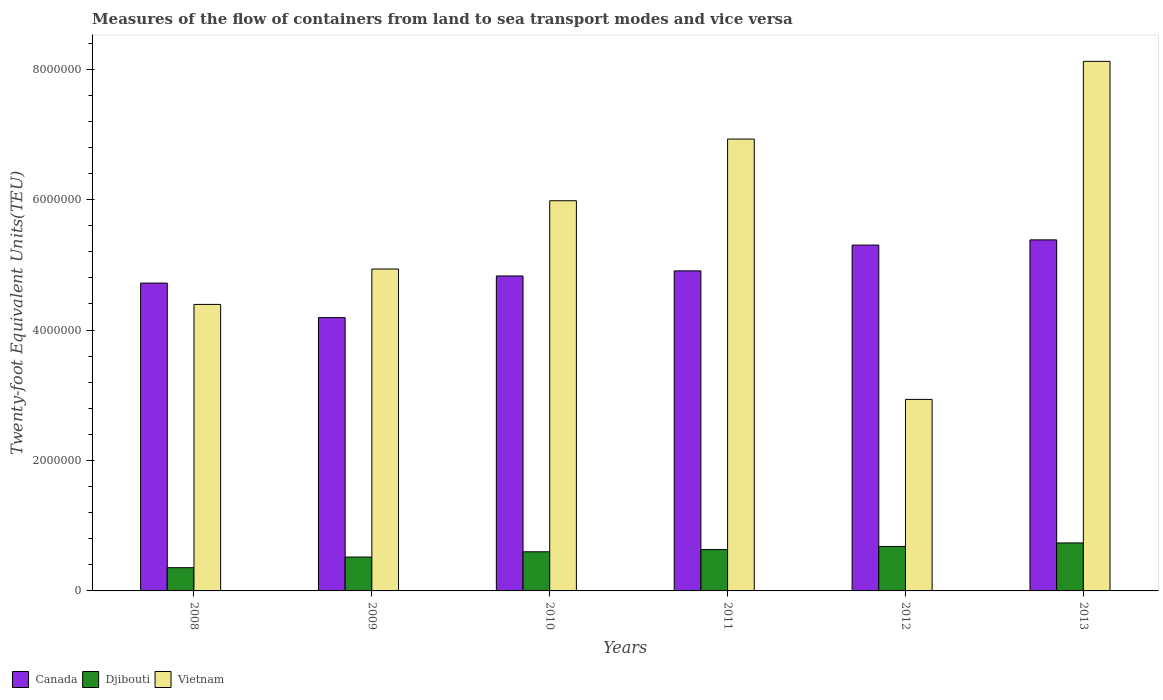How many different coloured bars are there?
Make the answer very short. 3. Are the number of bars per tick equal to the number of legend labels?
Provide a short and direct response. Yes. How many bars are there on the 1st tick from the left?
Ensure brevity in your answer.  3. What is the label of the 4th group of bars from the left?
Your answer should be compact. 2011. What is the container port traffic in Vietnam in 2008?
Ensure brevity in your answer.  4.39e+06. Across all years, what is the maximum container port traffic in Canada?
Your answer should be very brief. 5.38e+06. Across all years, what is the minimum container port traffic in Vietnam?
Your answer should be compact. 2.94e+06. What is the total container port traffic in Djibouti in the graph?
Give a very brief answer. 3.53e+06. What is the difference between the container port traffic in Canada in 2012 and that in 2013?
Make the answer very short. -7.98e+04. What is the difference between the container port traffic in Canada in 2009 and the container port traffic in Djibouti in 2012?
Make the answer very short. 3.51e+06. What is the average container port traffic in Djibouti per year?
Give a very brief answer. 5.88e+05. In the year 2008, what is the difference between the container port traffic in Djibouti and container port traffic in Vietnam?
Your answer should be very brief. -4.04e+06. What is the ratio of the container port traffic in Canada in 2009 to that in 2012?
Keep it short and to the point. 0.79. Is the difference between the container port traffic in Djibouti in 2009 and 2013 greater than the difference between the container port traffic in Vietnam in 2009 and 2013?
Your answer should be compact. Yes. What is the difference between the highest and the second highest container port traffic in Vietnam?
Make the answer very short. 1.19e+06. What is the difference between the highest and the lowest container port traffic in Vietnam?
Ensure brevity in your answer.  5.18e+06. In how many years, is the container port traffic in Canada greater than the average container port traffic in Canada taken over all years?
Your answer should be very brief. 3. What does the 2nd bar from the left in 2011 represents?
Keep it short and to the point. Djibouti. What does the 3rd bar from the right in 2012 represents?
Give a very brief answer. Canada. How many bars are there?
Keep it short and to the point. 18. What is the difference between two consecutive major ticks on the Y-axis?
Offer a terse response. 2.00e+06. Are the values on the major ticks of Y-axis written in scientific E-notation?
Keep it short and to the point. No. Does the graph contain any zero values?
Your response must be concise. No. Does the graph contain grids?
Make the answer very short. No. What is the title of the graph?
Offer a terse response. Measures of the flow of containers from land to sea transport modes and vice versa. What is the label or title of the Y-axis?
Ensure brevity in your answer.  Twenty-foot Equivalent Units(TEU). What is the Twenty-foot Equivalent Units(TEU) of Canada in 2008?
Provide a short and direct response. 4.72e+06. What is the Twenty-foot Equivalent Units(TEU) in Djibouti in 2008?
Your answer should be very brief. 3.56e+05. What is the Twenty-foot Equivalent Units(TEU) of Vietnam in 2008?
Your answer should be very brief. 4.39e+06. What is the Twenty-foot Equivalent Units(TEU) in Canada in 2009?
Provide a succinct answer. 4.19e+06. What is the Twenty-foot Equivalent Units(TEU) in Djibouti in 2009?
Provide a succinct answer. 5.20e+05. What is the Twenty-foot Equivalent Units(TEU) of Vietnam in 2009?
Your answer should be very brief. 4.94e+06. What is the Twenty-foot Equivalent Units(TEU) in Canada in 2010?
Ensure brevity in your answer.  4.83e+06. What is the Twenty-foot Equivalent Units(TEU) of Vietnam in 2010?
Offer a terse response. 5.98e+06. What is the Twenty-foot Equivalent Units(TEU) in Canada in 2011?
Your answer should be compact. 4.91e+06. What is the Twenty-foot Equivalent Units(TEU) in Djibouti in 2011?
Your response must be concise. 6.34e+05. What is the Twenty-foot Equivalent Units(TEU) in Vietnam in 2011?
Offer a terse response. 6.93e+06. What is the Twenty-foot Equivalent Units(TEU) of Canada in 2012?
Provide a succinct answer. 5.30e+06. What is the Twenty-foot Equivalent Units(TEU) of Djibouti in 2012?
Provide a succinct answer. 6.82e+05. What is the Twenty-foot Equivalent Units(TEU) of Vietnam in 2012?
Your answer should be compact. 2.94e+06. What is the Twenty-foot Equivalent Units(TEU) in Canada in 2013?
Keep it short and to the point. 5.38e+06. What is the Twenty-foot Equivalent Units(TEU) of Djibouti in 2013?
Give a very brief answer. 7.36e+05. What is the Twenty-foot Equivalent Units(TEU) in Vietnam in 2013?
Ensure brevity in your answer.  8.12e+06. Across all years, what is the maximum Twenty-foot Equivalent Units(TEU) of Canada?
Provide a succinct answer. 5.38e+06. Across all years, what is the maximum Twenty-foot Equivalent Units(TEU) in Djibouti?
Provide a succinct answer. 7.36e+05. Across all years, what is the maximum Twenty-foot Equivalent Units(TEU) of Vietnam?
Offer a very short reply. 8.12e+06. Across all years, what is the minimum Twenty-foot Equivalent Units(TEU) in Canada?
Your answer should be compact. 4.19e+06. Across all years, what is the minimum Twenty-foot Equivalent Units(TEU) of Djibouti?
Provide a succinct answer. 3.56e+05. Across all years, what is the minimum Twenty-foot Equivalent Units(TEU) in Vietnam?
Keep it short and to the point. 2.94e+06. What is the total Twenty-foot Equivalent Units(TEU) of Canada in the graph?
Your response must be concise. 2.93e+07. What is the total Twenty-foot Equivalent Units(TEU) in Djibouti in the graph?
Your answer should be compact. 3.53e+06. What is the total Twenty-foot Equivalent Units(TEU) of Vietnam in the graph?
Give a very brief answer. 3.33e+07. What is the difference between the Twenty-foot Equivalent Units(TEU) of Canada in 2008 and that in 2009?
Ensure brevity in your answer.  5.29e+05. What is the difference between the Twenty-foot Equivalent Units(TEU) in Djibouti in 2008 and that in 2009?
Ensure brevity in your answer.  -1.63e+05. What is the difference between the Twenty-foot Equivalent Units(TEU) in Vietnam in 2008 and that in 2009?
Provide a short and direct response. -5.43e+05. What is the difference between the Twenty-foot Equivalent Units(TEU) in Canada in 2008 and that in 2010?
Make the answer very short. -1.09e+05. What is the difference between the Twenty-foot Equivalent Units(TEU) of Djibouti in 2008 and that in 2010?
Your response must be concise. -2.44e+05. What is the difference between the Twenty-foot Equivalent Units(TEU) in Vietnam in 2008 and that in 2010?
Make the answer very short. -1.59e+06. What is the difference between the Twenty-foot Equivalent Units(TEU) in Canada in 2008 and that in 2011?
Your answer should be very brief. -1.87e+05. What is the difference between the Twenty-foot Equivalent Units(TEU) of Djibouti in 2008 and that in 2011?
Ensure brevity in your answer.  -2.78e+05. What is the difference between the Twenty-foot Equivalent Units(TEU) in Vietnam in 2008 and that in 2011?
Your answer should be compact. -2.54e+06. What is the difference between the Twenty-foot Equivalent Units(TEU) of Canada in 2008 and that in 2012?
Provide a short and direct response. -5.83e+05. What is the difference between the Twenty-foot Equivalent Units(TEU) of Djibouti in 2008 and that in 2012?
Make the answer very short. -3.25e+05. What is the difference between the Twenty-foot Equivalent Units(TEU) in Vietnam in 2008 and that in 2012?
Provide a succinct answer. 1.46e+06. What is the difference between the Twenty-foot Equivalent Units(TEU) of Canada in 2008 and that in 2013?
Keep it short and to the point. -6.63e+05. What is the difference between the Twenty-foot Equivalent Units(TEU) of Djibouti in 2008 and that in 2013?
Ensure brevity in your answer.  -3.79e+05. What is the difference between the Twenty-foot Equivalent Units(TEU) of Vietnam in 2008 and that in 2013?
Ensure brevity in your answer.  -3.73e+06. What is the difference between the Twenty-foot Equivalent Units(TEU) of Canada in 2009 and that in 2010?
Offer a very short reply. -6.38e+05. What is the difference between the Twenty-foot Equivalent Units(TEU) in Djibouti in 2009 and that in 2010?
Give a very brief answer. -8.05e+04. What is the difference between the Twenty-foot Equivalent Units(TEU) in Vietnam in 2009 and that in 2010?
Offer a terse response. -1.05e+06. What is the difference between the Twenty-foot Equivalent Units(TEU) of Canada in 2009 and that in 2011?
Your response must be concise. -7.17e+05. What is the difference between the Twenty-foot Equivalent Units(TEU) in Djibouti in 2009 and that in 2011?
Provide a short and direct response. -1.15e+05. What is the difference between the Twenty-foot Equivalent Units(TEU) in Vietnam in 2009 and that in 2011?
Make the answer very short. -1.99e+06. What is the difference between the Twenty-foot Equivalent Units(TEU) of Canada in 2009 and that in 2012?
Provide a short and direct response. -1.11e+06. What is the difference between the Twenty-foot Equivalent Units(TEU) in Djibouti in 2009 and that in 2012?
Provide a short and direct response. -1.62e+05. What is the difference between the Twenty-foot Equivalent Units(TEU) of Vietnam in 2009 and that in 2012?
Provide a succinct answer. 2.00e+06. What is the difference between the Twenty-foot Equivalent Units(TEU) in Canada in 2009 and that in 2013?
Ensure brevity in your answer.  -1.19e+06. What is the difference between the Twenty-foot Equivalent Units(TEU) in Djibouti in 2009 and that in 2013?
Give a very brief answer. -2.16e+05. What is the difference between the Twenty-foot Equivalent Units(TEU) in Vietnam in 2009 and that in 2013?
Offer a terse response. -3.18e+06. What is the difference between the Twenty-foot Equivalent Units(TEU) of Canada in 2010 and that in 2011?
Your response must be concise. -7.83e+04. What is the difference between the Twenty-foot Equivalent Units(TEU) in Djibouti in 2010 and that in 2011?
Your answer should be very brief. -3.42e+04. What is the difference between the Twenty-foot Equivalent Units(TEU) in Vietnam in 2010 and that in 2011?
Your response must be concise. -9.46e+05. What is the difference between the Twenty-foot Equivalent Units(TEU) in Canada in 2010 and that in 2012?
Provide a succinct answer. -4.74e+05. What is the difference between the Twenty-foot Equivalent Units(TEU) in Djibouti in 2010 and that in 2012?
Give a very brief answer. -8.18e+04. What is the difference between the Twenty-foot Equivalent Units(TEU) of Vietnam in 2010 and that in 2012?
Your answer should be very brief. 3.05e+06. What is the difference between the Twenty-foot Equivalent Units(TEU) of Canada in 2010 and that in 2013?
Keep it short and to the point. -5.54e+05. What is the difference between the Twenty-foot Equivalent Units(TEU) in Djibouti in 2010 and that in 2013?
Keep it short and to the point. -1.36e+05. What is the difference between the Twenty-foot Equivalent Units(TEU) of Vietnam in 2010 and that in 2013?
Offer a very short reply. -2.14e+06. What is the difference between the Twenty-foot Equivalent Units(TEU) in Canada in 2011 and that in 2012?
Your answer should be very brief. -3.96e+05. What is the difference between the Twenty-foot Equivalent Units(TEU) of Djibouti in 2011 and that in 2012?
Make the answer very short. -4.76e+04. What is the difference between the Twenty-foot Equivalent Units(TEU) in Vietnam in 2011 and that in 2012?
Give a very brief answer. 3.99e+06. What is the difference between the Twenty-foot Equivalent Units(TEU) of Canada in 2011 and that in 2013?
Your answer should be compact. -4.75e+05. What is the difference between the Twenty-foot Equivalent Units(TEU) of Djibouti in 2011 and that in 2013?
Give a very brief answer. -1.01e+05. What is the difference between the Twenty-foot Equivalent Units(TEU) of Vietnam in 2011 and that in 2013?
Keep it short and to the point. -1.19e+06. What is the difference between the Twenty-foot Equivalent Units(TEU) in Canada in 2012 and that in 2013?
Your answer should be compact. -7.98e+04. What is the difference between the Twenty-foot Equivalent Units(TEU) in Djibouti in 2012 and that in 2013?
Your answer should be compact. -5.39e+04. What is the difference between the Twenty-foot Equivalent Units(TEU) of Vietnam in 2012 and that in 2013?
Ensure brevity in your answer.  -5.18e+06. What is the difference between the Twenty-foot Equivalent Units(TEU) in Canada in 2008 and the Twenty-foot Equivalent Units(TEU) in Djibouti in 2009?
Your response must be concise. 4.20e+06. What is the difference between the Twenty-foot Equivalent Units(TEU) in Canada in 2008 and the Twenty-foot Equivalent Units(TEU) in Vietnam in 2009?
Make the answer very short. -2.16e+05. What is the difference between the Twenty-foot Equivalent Units(TEU) in Djibouti in 2008 and the Twenty-foot Equivalent Units(TEU) in Vietnam in 2009?
Offer a terse response. -4.58e+06. What is the difference between the Twenty-foot Equivalent Units(TEU) of Canada in 2008 and the Twenty-foot Equivalent Units(TEU) of Djibouti in 2010?
Give a very brief answer. 4.12e+06. What is the difference between the Twenty-foot Equivalent Units(TEU) of Canada in 2008 and the Twenty-foot Equivalent Units(TEU) of Vietnam in 2010?
Ensure brevity in your answer.  -1.26e+06. What is the difference between the Twenty-foot Equivalent Units(TEU) of Djibouti in 2008 and the Twenty-foot Equivalent Units(TEU) of Vietnam in 2010?
Offer a very short reply. -5.63e+06. What is the difference between the Twenty-foot Equivalent Units(TEU) in Canada in 2008 and the Twenty-foot Equivalent Units(TEU) in Djibouti in 2011?
Keep it short and to the point. 4.09e+06. What is the difference between the Twenty-foot Equivalent Units(TEU) of Canada in 2008 and the Twenty-foot Equivalent Units(TEU) of Vietnam in 2011?
Offer a very short reply. -2.21e+06. What is the difference between the Twenty-foot Equivalent Units(TEU) of Djibouti in 2008 and the Twenty-foot Equivalent Units(TEU) of Vietnam in 2011?
Make the answer very short. -6.57e+06. What is the difference between the Twenty-foot Equivalent Units(TEU) in Canada in 2008 and the Twenty-foot Equivalent Units(TEU) in Djibouti in 2012?
Your answer should be very brief. 4.04e+06. What is the difference between the Twenty-foot Equivalent Units(TEU) in Canada in 2008 and the Twenty-foot Equivalent Units(TEU) in Vietnam in 2012?
Your answer should be compact. 1.78e+06. What is the difference between the Twenty-foot Equivalent Units(TEU) in Djibouti in 2008 and the Twenty-foot Equivalent Units(TEU) in Vietnam in 2012?
Ensure brevity in your answer.  -2.58e+06. What is the difference between the Twenty-foot Equivalent Units(TEU) in Canada in 2008 and the Twenty-foot Equivalent Units(TEU) in Djibouti in 2013?
Your answer should be very brief. 3.99e+06. What is the difference between the Twenty-foot Equivalent Units(TEU) in Canada in 2008 and the Twenty-foot Equivalent Units(TEU) in Vietnam in 2013?
Ensure brevity in your answer.  -3.40e+06. What is the difference between the Twenty-foot Equivalent Units(TEU) of Djibouti in 2008 and the Twenty-foot Equivalent Units(TEU) of Vietnam in 2013?
Give a very brief answer. -7.76e+06. What is the difference between the Twenty-foot Equivalent Units(TEU) of Canada in 2009 and the Twenty-foot Equivalent Units(TEU) of Djibouti in 2010?
Your answer should be very brief. 3.59e+06. What is the difference between the Twenty-foot Equivalent Units(TEU) in Canada in 2009 and the Twenty-foot Equivalent Units(TEU) in Vietnam in 2010?
Provide a short and direct response. -1.79e+06. What is the difference between the Twenty-foot Equivalent Units(TEU) in Djibouti in 2009 and the Twenty-foot Equivalent Units(TEU) in Vietnam in 2010?
Offer a terse response. -5.46e+06. What is the difference between the Twenty-foot Equivalent Units(TEU) of Canada in 2009 and the Twenty-foot Equivalent Units(TEU) of Djibouti in 2011?
Your answer should be compact. 3.56e+06. What is the difference between the Twenty-foot Equivalent Units(TEU) in Canada in 2009 and the Twenty-foot Equivalent Units(TEU) in Vietnam in 2011?
Provide a short and direct response. -2.74e+06. What is the difference between the Twenty-foot Equivalent Units(TEU) in Djibouti in 2009 and the Twenty-foot Equivalent Units(TEU) in Vietnam in 2011?
Offer a very short reply. -6.41e+06. What is the difference between the Twenty-foot Equivalent Units(TEU) in Canada in 2009 and the Twenty-foot Equivalent Units(TEU) in Djibouti in 2012?
Offer a terse response. 3.51e+06. What is the difference between the Twenty-foot Equivalent Units(TEU) of Canada in 2009 and the Twenty-foot Equivalent Units(TEU) of Vietnam in 2012?
Provide a short and direct response. 1.25e+06. What is the difference between the Twenty-foot Equivalent Units(TEU) of Djibouti in 2009 and the Twenty-foot Equivalent Units(TEU) of Vietnam in 2012?
Keep it short and to the point. -2.42e+06. What is the difference between the Twenty-foot Equivalent Units(TEU) of Canada in 2009 and the Twenty-foot Equivalent Units(TEU) of Djibouti in 2013?
Your answer should be very brief. 3.46e+06. What is the difference between the Twenty-foot Equivalent Units(TEU) of Canada in 2009 and the Twenty-foot Equivalent Units(TEU) of Vietnam in 2013?
Make the answer very short. -3.93e+06. What is the difference between the Twenty-foot Equivalent Units(TEU) of Djibouti in 2009 and the Twenty-foot Equivalent Units(TEU) of Vietnam in 2013?
Provide a succinct answer. -7.60e+06. What is the difference between the Twenty-foot Equivalent Units(TEU) in Canada in 2010 and the Twenty-foot Equivalent Units(TEU) in Djibouti in 2011?
Offer a very short reply. 4.20e+06. What is the difference between the Twenty-foot Equivalent Units(TEU) in Canada in 2010 and the Twenty-foot Equivalent Units(TEU) in Vietnam in 2011?
Provide a short and direct response. -2.10e+06. What is the difference between the Twenty-foot Equivalent Units(TEU) of Djibouti in 2010 and the Twenty-foot Equivalent Units(TEU) of Vietnam in 2011?
Offer a very short reply. -6.33e+06. What is the difference between the Twenty-foot Equivalent Units(TEU) of Canada in 2010 and the Twenty-foot Equivalent Units(TEU) of Djibouti in 2012?
Make the answer very short. 4.15e+06. What is the difference between the Twenty-foot Equivalent Units(TEU) in Canada in 2010 and the Twenty-foot Equivalent Units(TEU) in Vietnam in 2012?
Your response must be concise. 1.89e+06. What is the difference between the Twenty-foot Equivalent Units(TEU) in Djibouti in 2010 and the Twenty-foot Equivalent Units(TEU) in Vietnam in 2012?
Give a very brief answer. -2.34e+06. What is the difference between the Twenty-foot Equivalent Units(TEU) in Canada in 2010 and the Twenty-foot Equivalent Units(TEU) in Djibouti in 2013?
Provide a succinct answer. 4.09e+06. What is the difference between the Twenty-foot Equivalent Units(TEU) in Canada in 2010 and the Twenty-foot Equivalent Units(TEU) in Vietnam in 2013?
Your answer should be very brief. -3.29e+06. What is the difference between the Twenty-foot Equivalent Units(TEU) of Djibouti in 2010 and the Twenty-foot Equivalent Units(TEU) of Vietnam in 2013?
Your answer should be compact. -7.52e+06. What is the difference between the Twenty-foot Equivalent Units(TEU) of Canada in 2011 and the Twenty-foot Equivalent Units(TEU) of Djibouti in 2012?
Ensure brevity in your answer.  4.23e+06. What is the difference between the Twenty-foot Equivalent Units(TEU) in Canada in 2011 and the Twenty-foot Equivalent Units(TEU) in Vietnam in 2012?
Keep it short and to the point. 1.97e+06. What is the difference between the Twenty-foot Equivalent Units(TEU) of Djibouti in 2011 and the Twenty-foot Equivalent Units(TEU) of Vietnam in 2012?
Give a very brief answer. -2.30e+06. What is the difference between the Twenty-foot Equivalent Units(TEU) in Canada in 2011 and the Twenty-foot Equivalent Units(TEU) in Djibouti in 2013?
Your response must be concise. 4.17e+06. What is the difference between the Twenty-foot Equivalent Units(TEU) of Canada in 2011 and the Twenty-foot Equivalent Units(TEU) of Vietnam in 2013?
Offer a very short reply. -3.21e+06. What is the difference between the Twenty-foot Equivalent Units(TEU) of Djibouti in 2011 and the Twenty-foot Equivalent Units(TEU) of Vietnam in 2013?
Your answer should be very brief. -7.49e+06. What is the difference between the Twenty-foot Equivalent Units(TEU) in Canada in 2012 and the Twenty-foot Equivalent Units(TEU) in Djibouti in 2013?
Ensure brevity in your answer.  4.57e+06. What is the difference between the Twenty-foot Equivalent Units(TEU) of Canada in 2012 and the Twenty-foot Equivalent Units(TEU) of Vietnam in 2013?
Give a very brief answer. -2.82e+06. What is the difference between the Twenty-foot Equivalent Units(TEU) in Djibouti in 2012 and the Twenty-foot Equivalent Units(TEU) in Vietnam in 2013?
Offer a very short reply. -7.44e+06. What is the average Twenty-foot Equivalent Units(TEU) of Canada per year?
Make the answer very short. 4.89e+06. What is the average Twenty-foot Equivalent Units(TEU) of Djibouti per year?
Ensure brevity in your answer.  5.88e+05. What is the average Twenty-foot Equivalent Units(TEU) in Vietnam per year?
Your answer should be very brief. 5.55e+06. In the year 2008, what is the difference between the Twenty-foot Equivalent Units(TEU) in Canada and Twenty-foot Equivalent Units(TEU) in Djibouti?
Offer a terse response. 4.36e+06. In the year 2008, what is the difference between the Twenty-foot Equivalent Units(TEU) of Canada and Twenty-foot Equivalent Units(TEU) of Vietnam?
Give a very brief answer. 3.27e+05. In the year 2008, what is the difference between the Twenty-foot Equivalent Units(TEU) of Djibouti and Twenty-foot Equivalent Units(TEU) of Vietnam?
Offer a terse response. -4.04e+06. In the year 2009, what is the difference between the Twenty-foot Equivalent Units(TEU) of Canada and Twenty-foot Equivalent Units(TEU) of Djibouti?
Offer a terse response. 3.67e+06. In the year 2009, what is the difference between the Twenty-foot Equivalent Units(TEU) in Canada and Twenty-foot Equivalent Units(TEU) in Vietnam?
Your response must be concise. -7.45e+05. In the year 2009, what is the difference between the Twenty-foot Equivalent Units(TEU) in Djibouti and Twenty-foot Equivalent Units(TEU) in Vietnam?
Give a very brief answer. -4.42e+06. In the year 2010, what is the difference between the Twenty-foot Equivalent Units(TEU) of Canada and Twenty-foot Equivalent Units(TEU) of Djibouti?
Ensure brevity in your answer.  4.23e+06. In the year 2010, what is the difference between the Twenty-foot Equivalent Units(TEU) in Canada and Twenty-foot Equivalent Units(TEU) in Vietnam?
Your answer should be very brief. -1.15e+06. In the year 2010, what is the difference between the Twenty-foot Equivalent Units(TEU) of Djibouti and Twenty-foot Equivalent Units(TEU) of Vietnam?
Give a very brief answer. -5.38e+06. In the year 2011, what is the difference between the Twenty-foot Equivalent Units(TEU) of Canada and Twenty-foot Equivalent Units(TEU) of Djibouti?
Provide a succinct answer. 4.27e+06. In the year 2011, what is the difference between the Twenty-foot Equivalent Units(TEU) of Canada and Twenty-foot Equivalent Units(TEU) of Vietnam?
Provide a short and direct response. -2.02e+06. In the year 2011, what is the difference between the Twenty-foot Equivalent Units(TEU) of Djibouti and Twenty-foot Equivalent Units(TEU) of Vietnam?
Your answer should be very brief. -6.30e+06. In the year 2012, what is the difference between the Twenty-foot Equivalent Units(TEU) of Canada and Twenty-foot Equivalent Units(TEU) of Djibouti?
Give a very brief answer. 4.62e+06. In the year 2012, what is the difference between the Twenty-foot Equivalent Units(TEU) in Canada and Twenty-foot Equivalent Units(TEU) in Vietnam?
Provide a succinct answer. 2.37e+06. In the year 2012, what is the difference between the Twenty-foot Equivalent Units(TEU) in Djibouti and Twenty-foot Equivalent Units(TEU) in Vietnam?
Provide a short and direct response. -2.26e+06. In the year 2013, what is the difference between the Twenty-foot Equivalent Units(TEU) in Canada and Twenty-foot Equivalent Units(TEU) in Djibouti?
Your answer should be very brief. 4.65e+06. In the year 2013, what is the difference between the Twenty-foot Equivalent Units(TEU) in Canada and Twenty-foot Equivalent Units(TEU) in Vietnam?
Your answer should be compact. -2.74e+06. In the year 2013, what is the difference between the Twenty-foot Equivalent Units(TEU) of Djibouti and Twenty-foot Equivalent Units(TEU) of Vietnam?
Ensure brevity in your answer.  -7.39e+06. What is the ratio of the Twenty-foot Equivalent Units(TEU) of Canada in 2008 to that in 2009?
Ensure brevity in your answer.  1.13. What is the ratio of the Twenty-foot Equivalent Units(TEU) in Djibouti in 2008 to that in 2009?
Offer a very short reply. 0.69. What is the ratio of the Twenty-foot Equivalent Units(TEU) in Vietnam in 2008 to that in 2009?
Make the answer very short. 0.89. What is the ratio of the Twenty-foot Equivalent Units(TEU) of Canada in 2008 to that in 2010?
Ensure brevity in your answer.  0.98. What is the ratio of the Twenty-foot Equivalent Units(TEU) of Djibouti in 2008 to that in 2010?
Keep it short and to the point. 0.59. What is the ratio of the Twenty-foot Equivalent Units(TEU) in Vietnam in 2008 to that in 2010?
Your answer should be very brief. 0.73. What is the ratio of the Twenty-foot Equivalent Units(TEU) in Canada in 2008 to that in 2011?
Your answer should be very brief. 0.96. What is the ratio of the Twenty-foot Equivalent Units(TEU) of Djibouti in 2008 to that in 2011?
Your response must be concise. 0.56. What is the ratio of the Twenty-foot Equivalent Units(TEU) of Vietnam in 2008 to that in 2011?
Your response must be concise. 0.63. What is the ratio of the Twenty-foot Equivalent Units(TEU) of Canada in 2008 to that in 2012?
Ensure brevity in your answer.  0.89. What is the ratio of the Twenty-foot Equivalent Units(TEU) of Djibouti in 2008 to that in 2012?
Keep it short and to the point. 0.52. What is the ratio of the Twenty-foot Equivalent Units(TEU) of Vietnam in 2008 to that in 2012?
Your answer should be very brief. 1.5. What is the ratio of the Twenty-foot Equivalent Units(TEU) of Canada in 2008 to that in 2013?
Keep it short and to the point. 0.88. What is the ratio of the Twenty-foot Equivalent Units(TEU) in Djibouti in 2008 to that in 2013?
Offer a terse response. 0.48. What is the ratio of the Twenty-foot Equivalent Units(TEU) of Vietnam in 2008 to that in 2013?
Give a very brief answer. 0.54. What is the ratio of the Twenty-foot Equivalent Units(TEU) in Canada in 2009 to that in 2010?
Ensure brevity in your answer.  0.87. What is the ratio of the Twenty-foot Equivalent Units(TEU) in Djibouti in 2009 to that in 2010?
Your answer should be very brief. 0.87. What is the ratio of the Twenty-foot Equivalent Units(TEU) of Vietnam in 2009 to that in 2010?
Offer a very short reply. 0.82. What is the ratio of the Twenty-foot Equivalent Units(TEU) in Canada in 2009 to that in 2011?
Offer a very short reply. 0.85. What is the ratio of the Twenty-foot Equivalent Units(TEU) in Djibouti in 2009 to that in 2011?
Offer a very short reply. 0.82. What is the ratio of the Twenty-foot Equivalent Units(TEU) in Vietnam in 2009 to that in 2011?
Ensure brevity in your answer.  0.71. What is the ratio of the Twenty-foot Equivalent Units(TEU) of Canada in 2009 to that in 2012?
Give a very brief answer. 0.79. What is the ratio of the Twenty-foot Equivalent Units(TEU) of Djibouti in 2009 to that in 2012?
Give a very brief answer. 0.76. What is the ratio of the Twenty-foot Equivalent Units(TEU) in Vietnam in 2009 to that in 2012?
Ensure brevity in your answer.  1.68. What is the ratio of the Twenty-foot Equivalent Units(TEU) of Canada in 2009 to that in 2013?
Offer a very short reply. 0.78. What is the ratio of the Twenty-foot Equivalent Units(TEU) in Djibouti in 2009 to that in 2013?
Provide a short and direct response. 0.71. What is the ratio of the Twenty-foot Equivalent Units(TEU) of Vietnam in 2009 to that in 2013?
Provide a succinct answer. 0.61. What is the ratio of the Twenty-foot Equivalent Units(TEU) of Djibouti in 2010 to that in 2011?
Make the answer very short. 0.95. What is the ratio of the Twenty-foot Equivalent Units(TEU) in Vietnam in 2010 to that in 2011?
Ensure brevity in your answer.  0.86. What is the ratio of the Twenty-foot Equivalent Units(TEU) of Canada in 2010 to that in 2012?
Provide a succinct answer. 0.91. What is the ratio of the Twenty-foot Equivalent Units(TEU) of Djibouti in 2010 to that in 2012?
Give a very brief answer. 0.88. What is the ratio of the Twenty-foot Equivalent Units(TEU) of Vietnam in 2010 to that in 2012?
Your answer should be very brief. 2.04. What is the ratio of the Twenty-foot Equivalent Units(TEU) in Canada in 2010 to that in 2013?
Provide a succinct answer. 0.9. What is the ratio of the Twenty-foot Equivalent Units(TEU) of Djibouti in 2010 to that in 2013?
Provide a succinct answer. 0.82. What is the ratio of the Twenty-foot Equivalent Units(TEU) in Vietnam in 2010 to that in 2013?
Your answer should be compact. 0.74. What is the ratio of the Twenty-foot Equivalent Units(TEU) in Canada in 2011 to that in 2012?
Ensure brevity in your answer.  0.93. What is the ratio of the Twenty-foot Equivalent Units(TEU) of Djibouti in 2011 to that in 2012?
Your answer should be very brief. 0.93. What is the ratio of the Twenty-foot Equivalent Units(TEU) in Vietnam in 2011 to that in 2012?
Provide a short and direct response. 2.36. What is the ratio of the Twenty-foot Equivalent Units(TEU) of Canada in 2011 to that in 2013?
Give a very brief answer. 0.91. What is the ratio of the Twenty-foot Equivalent Units(TEU) of Djibouti in 2011 to that in 2013?
Your answer should be compact. 0.86. What is the ratio of the Twenty-foot Equivalent Units(TEU) of Vietnam in 2011 to that in 2013?
Your response must be concise. 0.85. What is the ratio of the Twenty-foot Equivalent Units(TEU) in Canada in 2012 to that in 2013?
Offer a very short reply. 0.99. What is the ratio of the Twenty-foot Equivalent Units(TEU) of Djibouti in 2012 to that in 2013?
Offer a very short reply. 0.93. What is the ratio of the Twenty-foot Equivalent Units(TEU) in Vietnam in 2012 to that in 2013?
Keep it short and to the point. 0.36. What is the difference between the highest and the second highest Twenty-foot Equivalent Units(TEU) of Canada?
Give a very brief answer. 7.98e+04. What is the difference between the highest and the second highest Twenty-foot Equivalent Units(TEU) of Djibouti?
Offer a terse response. 5.39e+04. What is the difference between the highest and the second highest Twenty-foot Equivalent Units(TEU) of Vietnam?
Your answer should be very brief. 1.19e+06. What is the difference between the highest and the lowest Twenty-foot Equivalent Units(TEU) in Canada?
Give a very brief answer. 1.19e+06. What is the difference between the highest and the lowest Twenty-foot Equivalent Units(TEU) of Djibouti?
Offer a terse response. 3.79e+05. What is the difference between the highest and the lowest Twenty-foot Equivalent Units(TEU) of Vietnam?
Your answer should be very brief. 5.18e+06. 